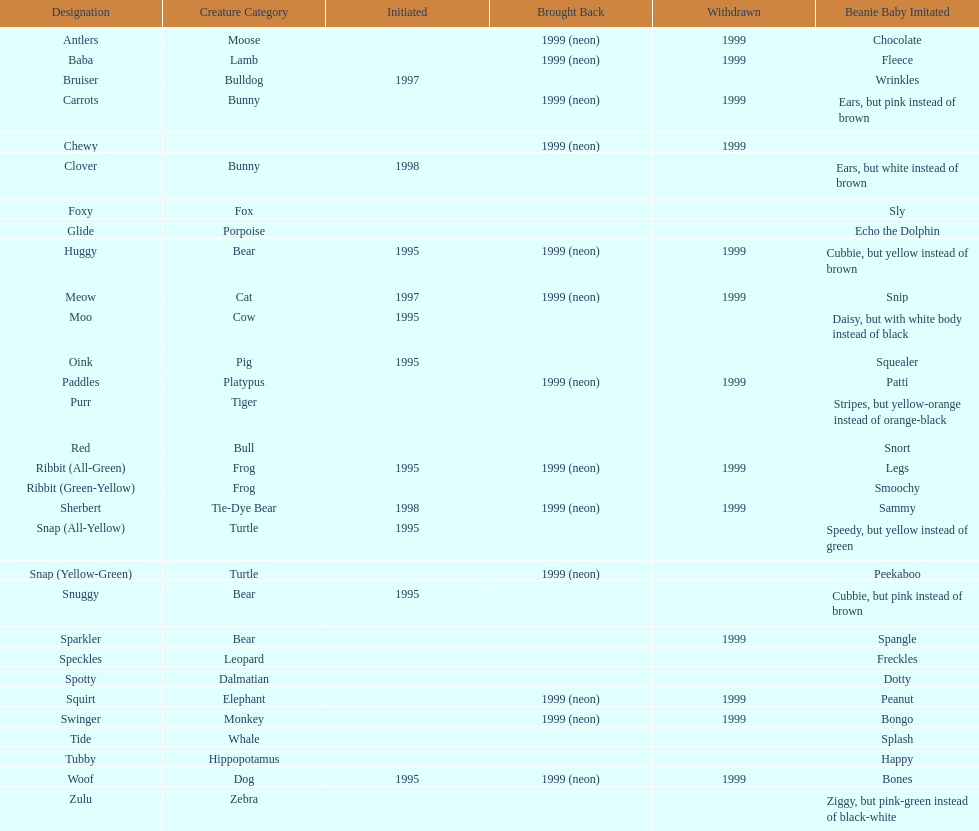Tell me the number of pillow pals reintroduced in 1999. 13. Give me the full table as a dictionary. {'header': ['Designation', 'Creature Category', 'Initiated', 'Brought Back', 'Withdrawn', 'Beanie Baby Imitated'], 'rows': [['Antlers', 'Moose', '', '1999 (neon)', '1999', 'Chocolate'], ['Baba', 'Lamb', '', '1999 (neon)', '1999', 'Fleece'], ['Bruiser', 'Bulldog', '1997', '', '', 'Wrinkles'], ['Carrots', 'Bunny', '', '1999 (neon)', '1999', 'Ears, but pink instead of brown'], ['Chewy', '', '', '1999 (neon)', '1999', ''], ['Clover', 'Bunny', '1998', '', '', 'Ears, but white instead of brown'], ['Foxy', 'Fox', '', '', '', 'Sly'], ['Glide', 'Porpoise', '', '', '', 'Echo the Dolphin'], ['Huggy', 'Bear', '1995', '1999 (neon)', '1999', 'Cubbie, but yellow instead of brown'], ['Meow', 'Cat', '1997', '1999 (neon)', '1999', 'Snip'], ['Moo', 'Cow', '1995', '', '', 'Daisy, but with white body instead of black'], ['Oink', 'Pig', '1995', '', '', 'Squealer'], ['Paddles', 'Platypus', '', '1999 (neon)', '1999', 'Patti'], ['Purr', 'Tiger', '', '', '', 'Stripes, but yellow-orange instead of orange-black'], ['Red', 'Bull', '', '', '', 'Snort'], ['Ribbit (All-Green)', 'Frog', '1995', '1999 (neon)', '1999', 'Legs'], ['Ribbit (Green-Yellow)', 'Frog', '', '', '', 'Smoochy'], ['Sherbert', 'Tie-Dye Bear', '1998', '1999 (neon)', '1999', 'Sammy'], ['Snap (All-Yellow)', 'Turtle', '1995', '', '', 'Speedy, but yellow instead of green'], ['Snap (Yellow-Green)', 'Turtle', '', '1999 (neon)', '', 'Peekaboo'], ['Snuggy', 'Bear', '1995', '', '', 'Cubbie, but pink instead of brown'], ['Sparkler', 'Bear', '', '', '1999', 'Spangle'], ['Speckles', 'Leopard', '', '', '', 'Freckles'], ['Spotty', 'Dalmatian', '', '', '', 'Dotty'], ['Squirt', 'Elephant', '', '1999 (neon)', '1999', 'Peanut'], ['Swinger', 'Monkey', '', '1999 (neon)', '1999', 'Bongo'], ['Tide', 'Whale', '', '', '', 'Splash'], ['Tubby', 'Hippopotamus', '', '', '', 'Happy'], ['Woof', 'Dog', '1995', '1999 (neon)', '1999', 'Bones'], ['Zulu', 'Zebra', '', '', '', 'Ziggy, but pink-green instead of black-white']]} 